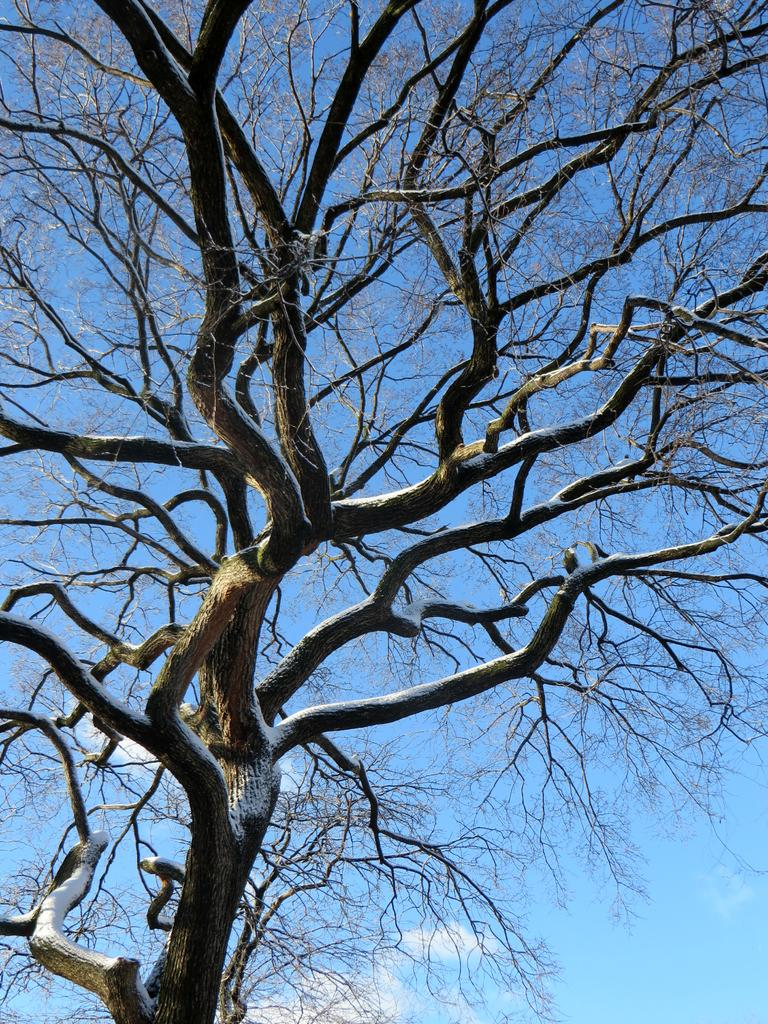What type of plant can be seen in the image? There is a tree in the image. What are the main features of the tree? The tree has branches and stems. What can be seen in the background of the image? The sky is visible in the background of the image. How many chairs are placed around the tree in the image? There are no chairs present in the image; it only features a tree with branches and stems against a sky background. 